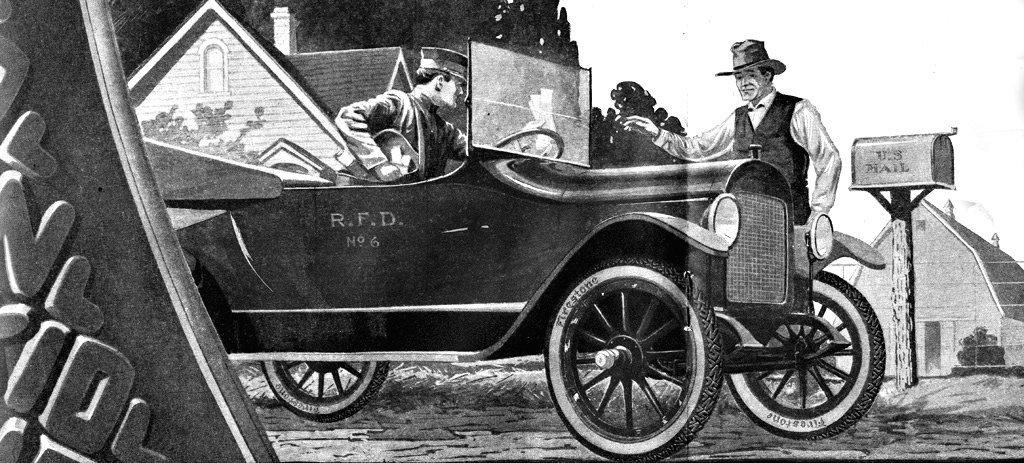What is on the road in the image? There is a vehicle on the road in the image. How many people are in the image? There are two persons in the image. What type of structures can be seen in the image? There are houses in the image. What object is associated with mail delivery in the image? There is a mailbox with a pole in the image. What part of the natural environment is visible in the image? The sky is visible in the image. Are there any girls in the image wearing zippers on their clothing? There is no information about clothing or girls in the image, so it cannot be determined if any girls are wearing zippers. 